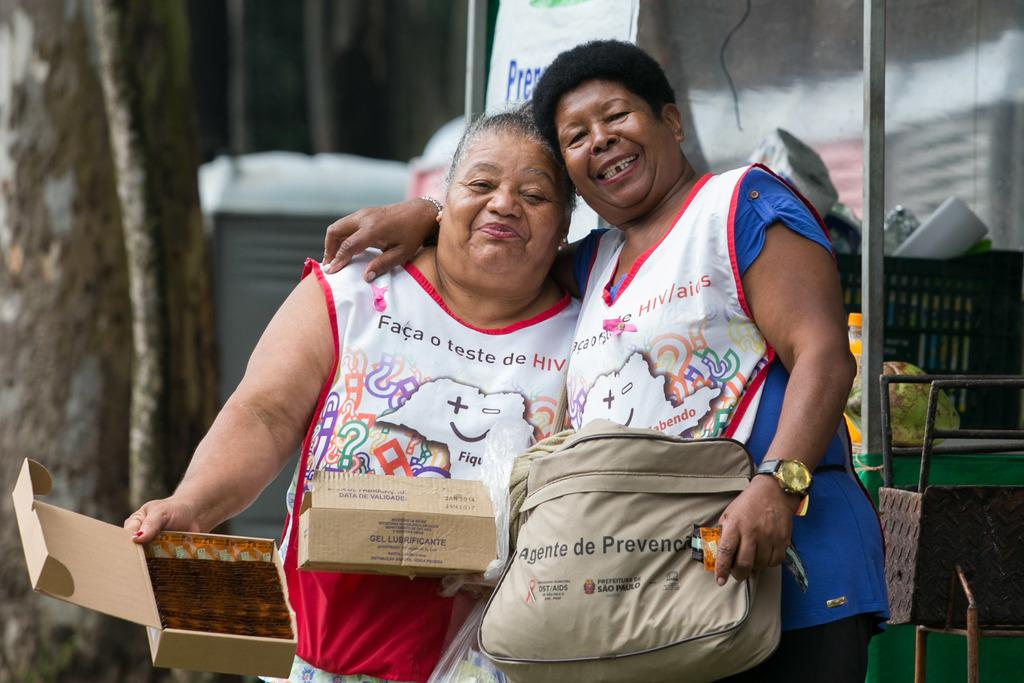<image>
Present a compact description of the photo's key features. Two women are wearing vests that say, 'Faca o teste de HIV/aids'. 